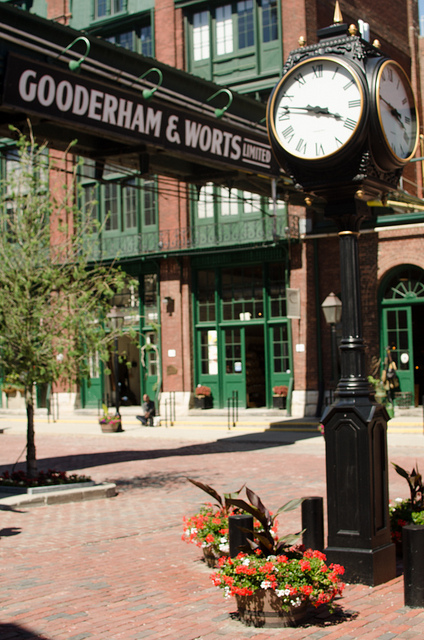Read all the text in this image. GOODERHAM WORTS LIMITED & 